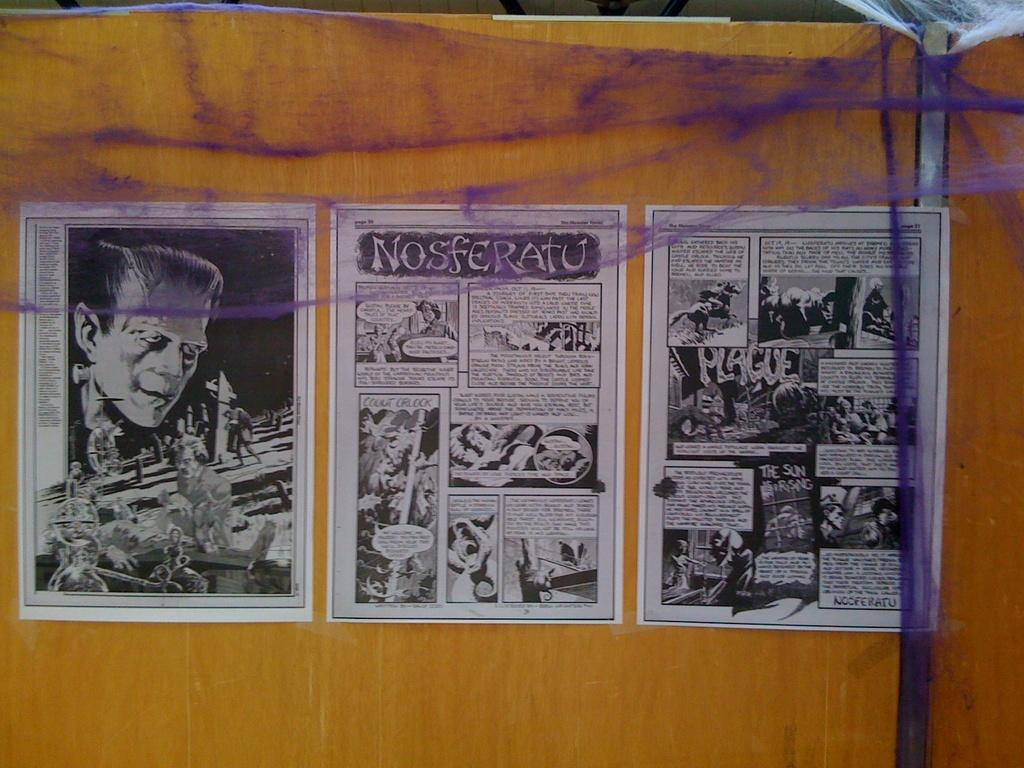<image>
Offer a succinct explanation of the picture presented. The comic series shown is Nosferatu and is in black and white 